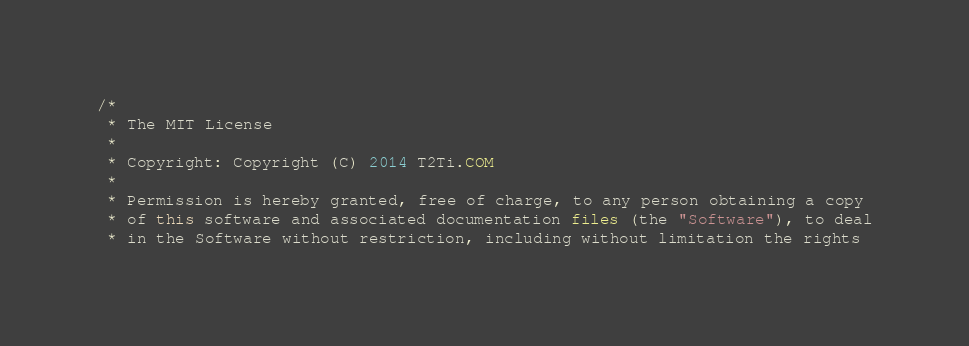<code> <loc_0><loc_0><loc_500><loc_500><_Java_>/*
 * The MIT License
 * 
 * Copyright: Copyright (C) 2014 T2Ti.COM
 * 
 * Permission is hereby granted, free of charge, to any person obtaining a copy
 * of this software and associated documentation files (the "Software"), to deal
 * in the Software without restriction, including without limitation the rights</code> 